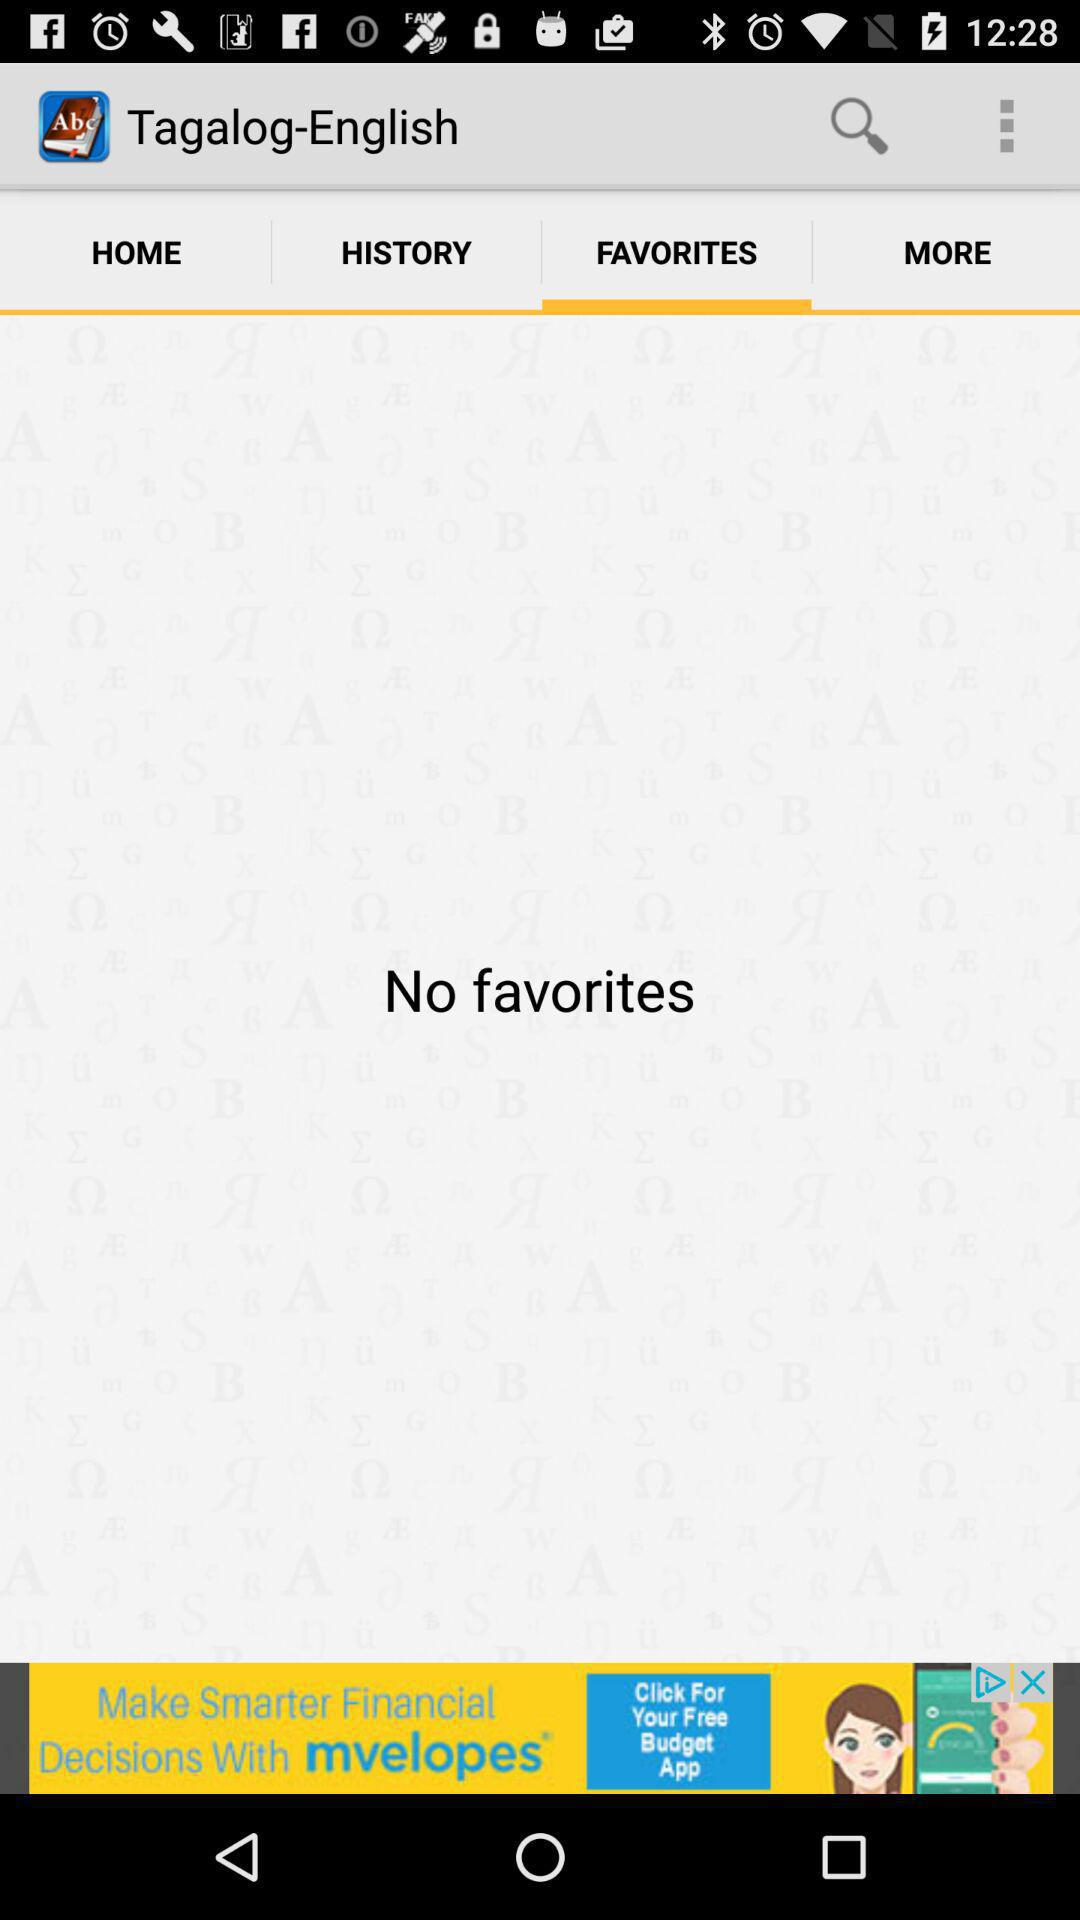Which tab is currently selected? The tab "FAVORITES" is currently selected. 